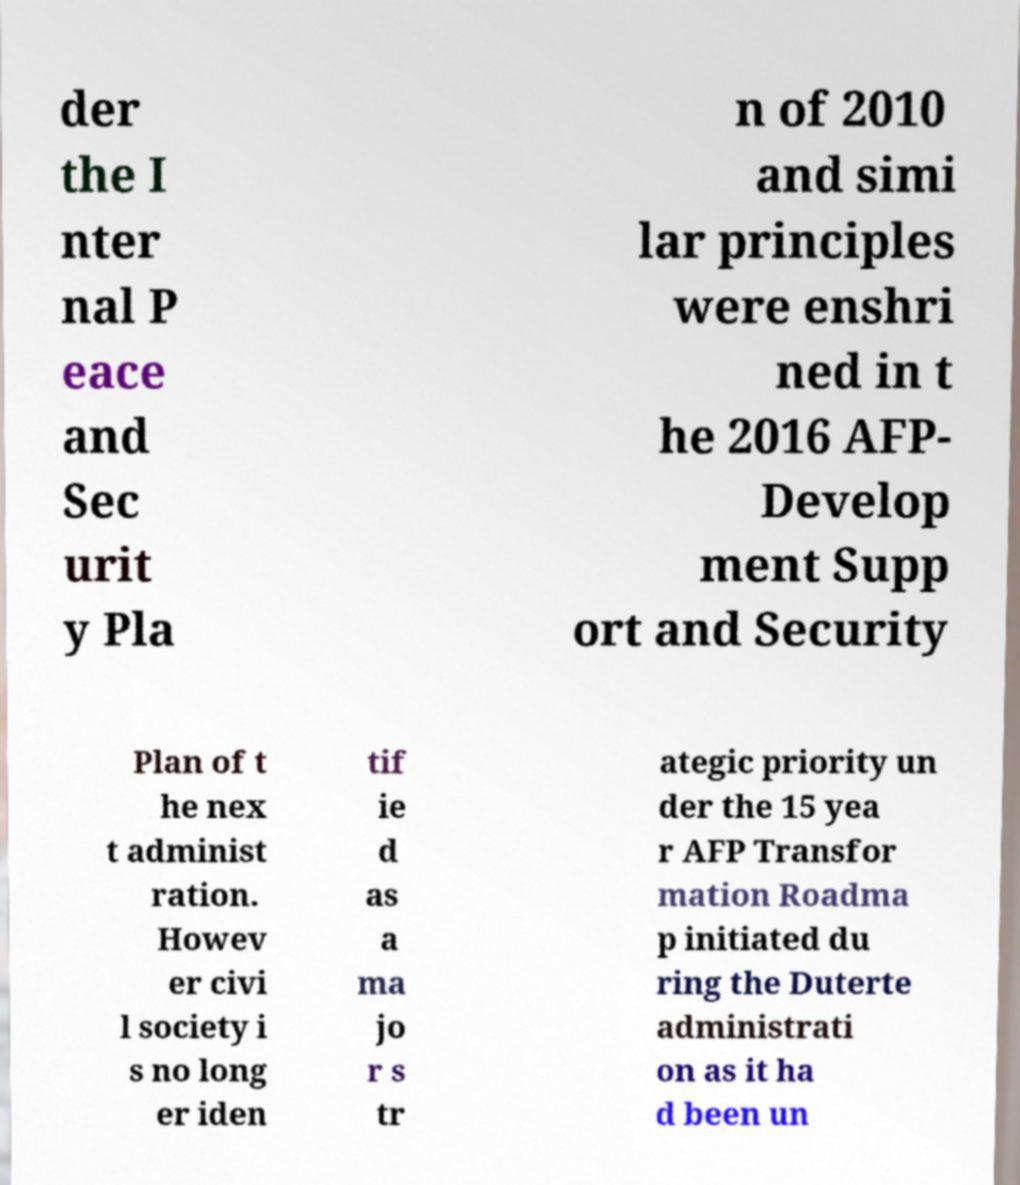Could you assist in decoding the text presented in this image and type it out clearly? der the I nter nal P eace and Sec urit y Pla n of 2010 and simi lar principles were enshri ned in t he 2016 AFP- Develop ment Supp ort and Security Plan of t he nex t administ ration. Howev er civi l society i s no long er iden tif ie d as a ma jo r s tr ategic priority un der the 15 yea r AFP Transfor mation Roadma p initiated du ring the Duterte administrati on as it ha d been un 